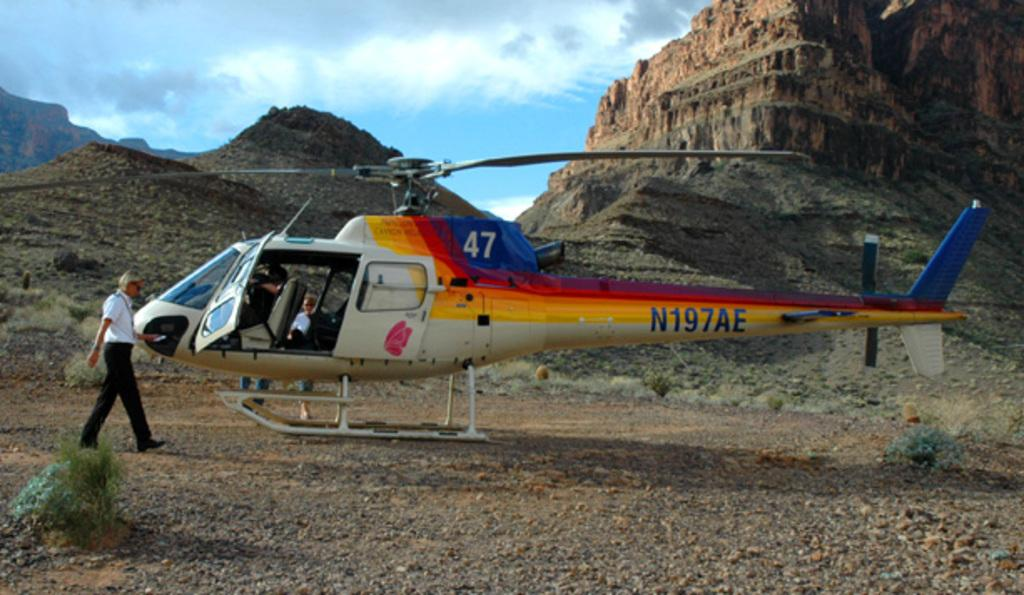Provide a one-sentence caption for the provided image. the helicopter sitting at the bottom of the mountain says 47. 